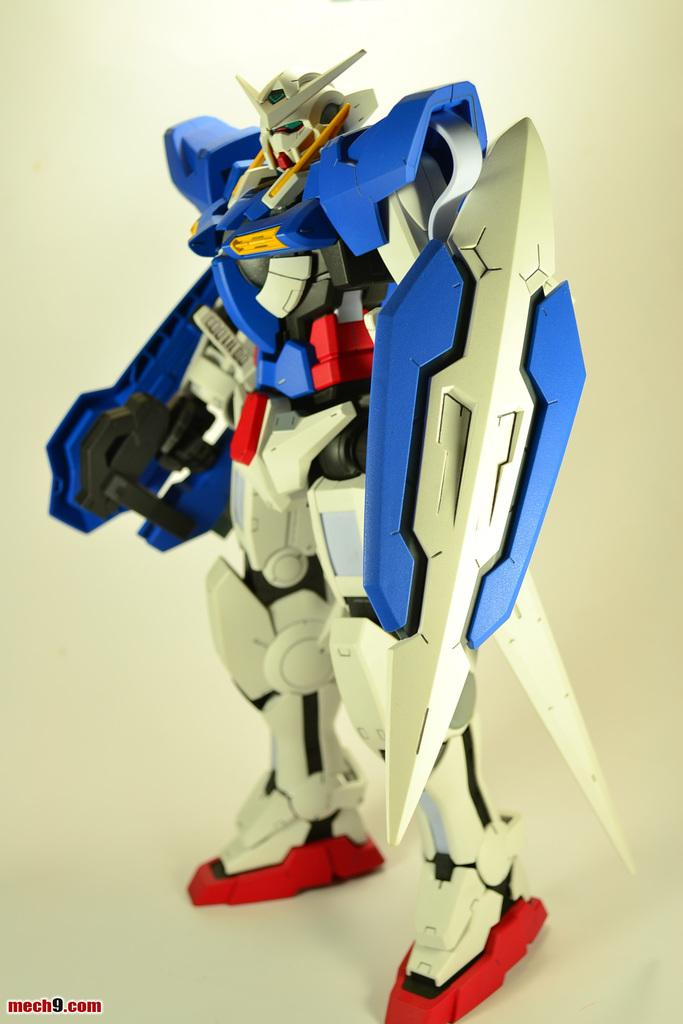What is the main object in the image? There is a toy in the image. What colors can be seen on the toy? The toy has colors white, blue, red, and yellow. What is the color of the surface in the image? The surface in the image is white. What type of toy is it? The toy is a watermark. Can you see any crayons being used to color the geese in the image? There are no crayons or geese present in the image. Is there any indication of payment being made for the toy in the image? There is no indication of payment being made in the image. 